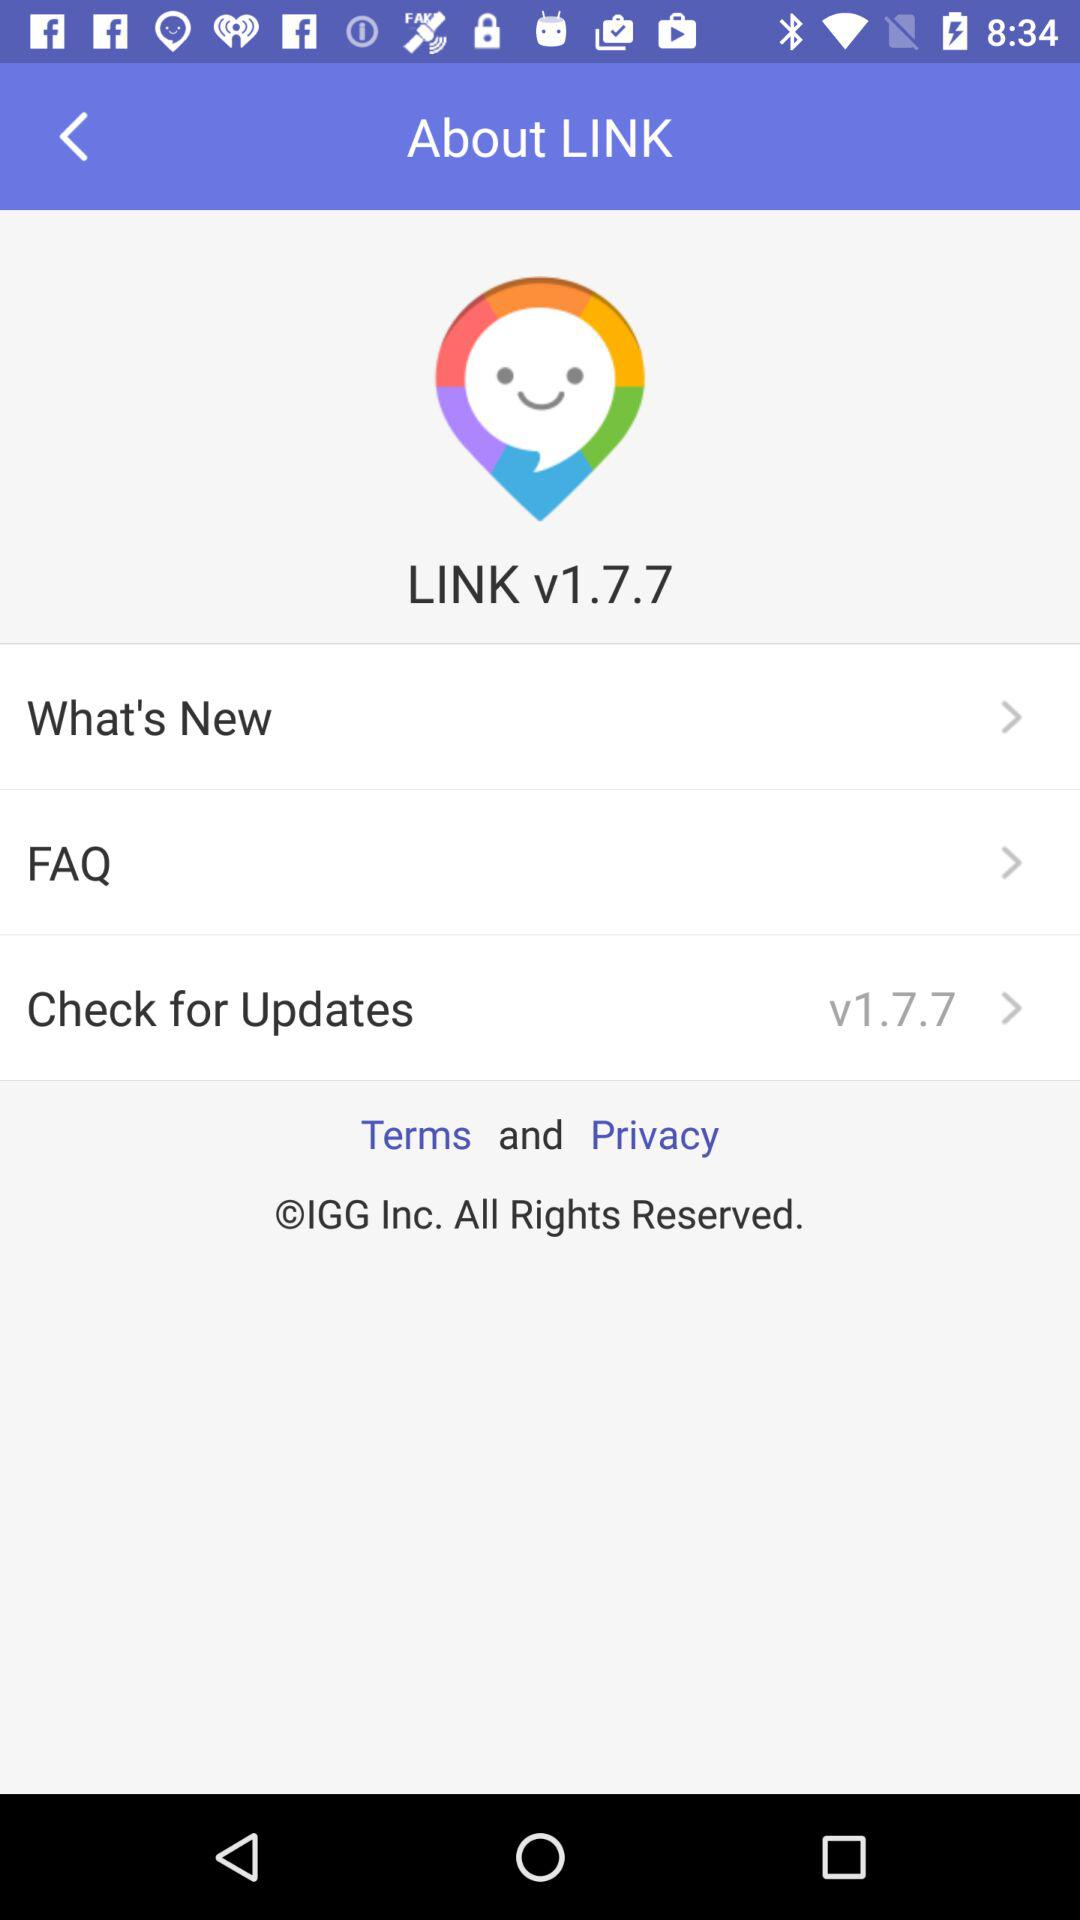What is the application name? The application name is "LINK". 